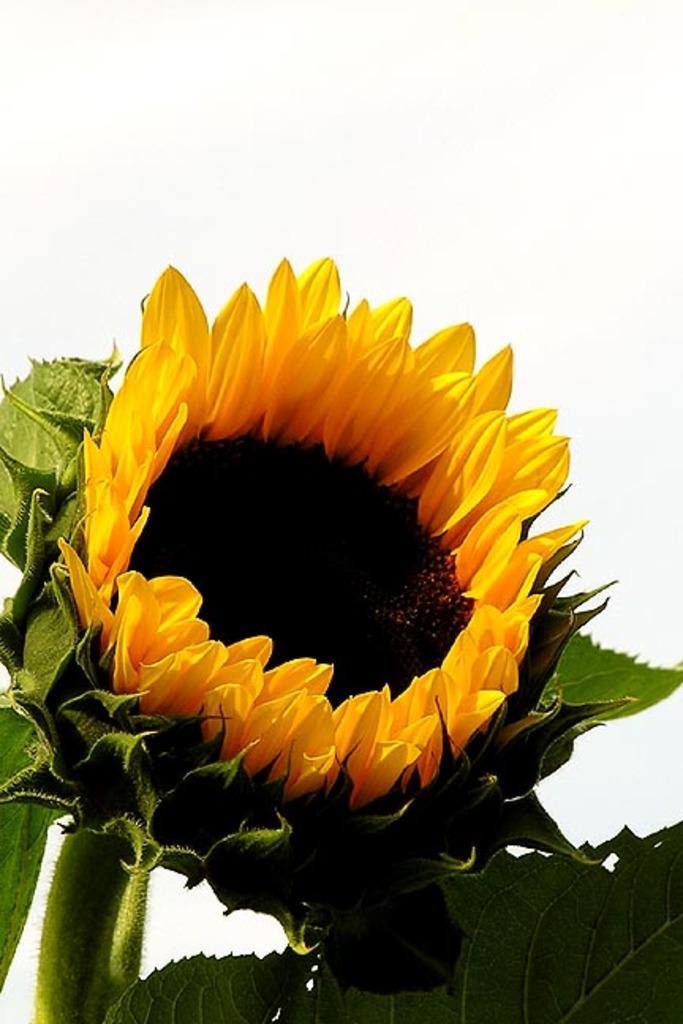What type of plant can be seen in the image? There is a flower in the image. What else is visible in the image besides the flower? There are leaves in the image. What type of drug is the queen discussing with the committee in the image? There is no queen, committee, or drug present in the image; it only features a flower and leaves. 